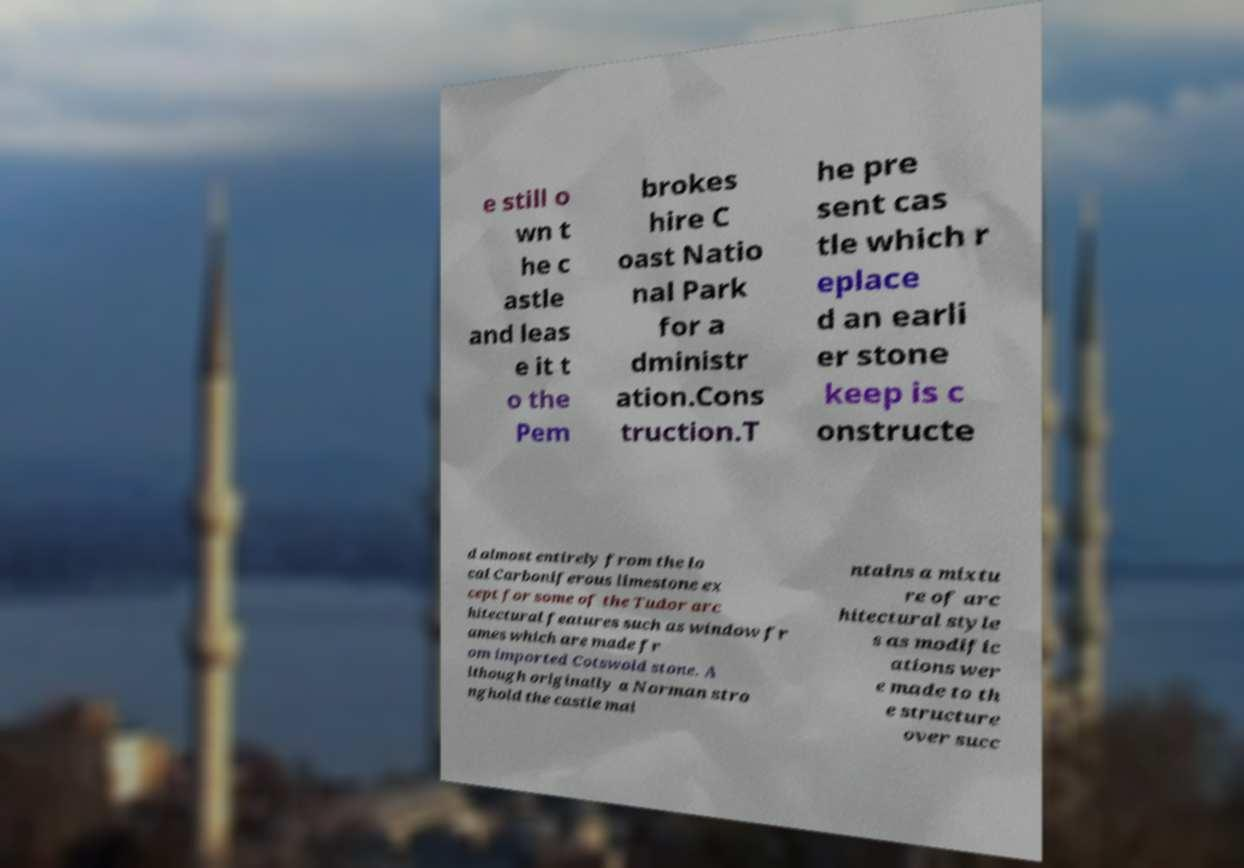Please identify and transcribe the text found in this image. e still o wn t he c astle and leas e it t o the Pem brokes hire C oast Natio nal Park for a dministr ation.Cons truction.T he pre sent cas tle which r eplace d an earli er stone keep is c onstructe d almost entirely from the lo cal Carboniferous limestone ex cept for some of the Tudor arc hitectural features such as window fr ames which are made fr om imported Cotswold stone. A lthough originally a Norman stro nghold the castle mai ntains a mixtu re of arc hitectural style s as modific ations wer e made to th e structure over succ 